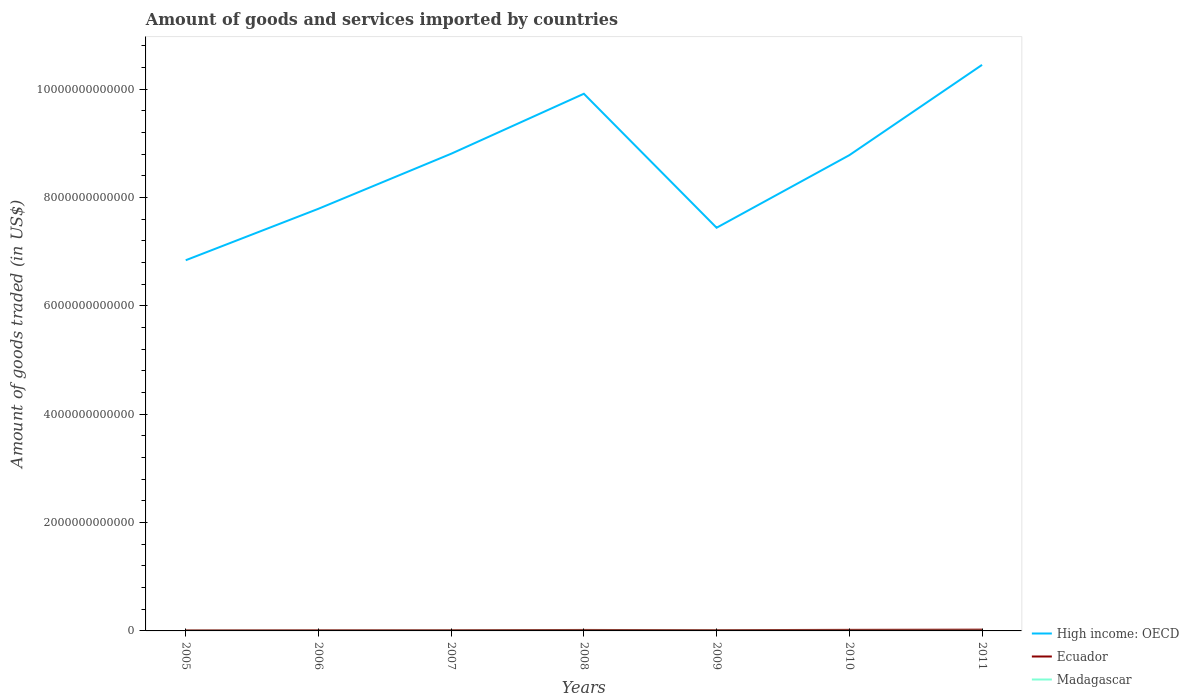Does the line corresponding to Madagascar intersect with the line corresponding to Ecuador?
Provide a succinct answer. No. Across all years, what is the maximum total amount of goods and services imported in Madagascar?
Offer a very short reply. 1.45e+09. In which year was the total amount of goods and services imported in Ecuador maximum?
Keep it short and to the point. 2005. What is the total total amount of goods and services imported in Ecuador in the graph?
Keep it short and to the point. -1.64e+09. What is the difference between the highest and the second highest total amount of goods and services imported in Madagascar?
Give a very brief answer. 1.76e+09. Is the total amount of goods and services imported in Madagascar strictly greater than the total amount of goods and services imported in Ecuador over the years?
Keep it short and to the point. Yes. How many years are there in the graph?
Offer a terse response. 7. What is the difference between two consecutive major ticks on the Y-axis?
Make the answer very short. 2.00e+12. Are the values on the major ticks of Y-axis written in scientific E-notation?
Provide a short and direct response. No. Where does the legend appear in the graph?
Your response must be concise. Bottom right. What is the title of the graph?
Your response must be concise. Amount of goods and services imported by countries. What is the label or title of the X-axis?
Provide a short and direct response. Years. What is the label or title of the Y-axis?
Offer a terse response. Amount of goods traded (in US$). What is the Amount of goods traded (in US$) in High income: OECD in 2005?
Make the answer very short. 6.84e+12. What is the Amount of goods traded (in US$) of Ecuador in 2005?
Provide a succinct answer. 9.70e+09. What is the Amount of goods traded (in US$) in Madagascar in 2005?
Your answer should be compact. 1.45e+09. What is the Amount of goods traded (in US$) in High income: OECD in 2006?
Ensure brevity in your answer.  7.79e+12. What is the Amount of goods traded (in US$) of Ecuador in 2006?
Give a very brief answer. 1.14e+1. What is the Amount of goods traded (in US$) of Madagascar in 2006?
Make the answer very short. 1.54e+09. What is the Amount of goods traded (in US$) in High income: OECD in 2007?
Give a very brief answer. 8.81e+12. What is the Amount of goods traded (in US$) of Ecuador in 2007?
Keep it short and to the point. 1.30e+1. What is the Amount of goods traded (in US$) in Madagascar in 2007?
Provide a short and direct response. 2.25e+09. What is the Amount of goods traded (in US$) of High income: OECD in 2008?
Make the answer very short. 9.91e+12. What is the Amount of goods traded (in US$) in Ecuador in 2008?
Provide a short and direct response. 1.79e+1. What is the Amount of goods traded (in US$) of Madagascar in 2008?
Offer a very short reply. 3.22e+09. What is the Amount of goods traded (in US$) in High income: OECD in 2009?
Your answer should be compact. 7.44e+12. What is the Amount of goods traded (in US$) in Ecuador in 2009?
Make the answer very short. 1.43e+1. What is the Amount of goods traded (in US$) in Madagascar in 2009?
Keep it short and to the point. 2.70e+09. What is the Amount of goods traded (in US$) in High income: OECD in 2010?
Your answer should be very brief. 8.78e+12. What is the Amount of goods traded (in US$) of Ecuador in 2010?
Provide a succinct answer. 1.96e+1. What is the Amount of goods traded (in US$) in Madagascar in 2010?
Your answer should be compact. 2.20e+09. What is the Amount of goods traded (in US$) in High income: OECD in 2011?
Your answer should be compact. 1.04e+13. What is the Amount of goods traded (in US$) of Ecuador in 2011?
Offer a very short reply. 2.32e+1. What is the Amount of goods traded (in US$) of Madagascar in 2011?
Offer a very short reply. 2.47e+09. Across all years, what is the maximum Amount of goods traded (in US$) of High income: OECD?
Your answer should be very brief. 1.04e+13. Across all years, what is the maximum Amount of goods traded (in US$) of Ecuador?
Provide a short and direct response. 2.32e+1. Across all years, what is the maximum Amount of goods traded (in US$) of Madagascar?
Provide a short and direct response. 3.22e+09. Across all years, what is the minimum Amount of goods traded (in US$) in High income: OECD?
Give a very brief answer. 6.84e+12. Across all years, what is the minimum Amount of goods traded (in US$) of Ecuador?
Ensure brevity in your answer.  9.70e+09. Across all years, what is the minimum Amount of goods traded (in US$) in Madagascar?
Offer a very short reply. 1.45e+09. What is the total Amount of goods traded (in US$) in High income: OECD in the graph?
Keep it short and to the point. 6.00e+13. What is the total Amount of goods traded (in US$) in Ecuador in the graph?
Ensure brevity in your answer.  1.09e+11. What is the total Amount of goods traded (in US$) of Madagascar in the graph?
Give a very brief answer. 1.58e+1. What is the difference between the Amount of goods traded (in US$) in High income: OECD in 2005 and that in 2006?
Offer a very short reply. -9.50e+11. What is the difference between the Amount of goods traded (in US$) in Ecuador in 2005 and that in 2006?
Provide a succinct answer. -1.70e+09. What is the difference between the Amount of goods traded (in US$) of Madagascar in 2005 and that in 2006?
Provide a succinct answer. -8.52e+07. What is the difference between the Amount of goods traded (in US$) in High income: OECD in 2005 and that in 2007?
Provide a succinct answer. -1.97e+12. What is the difference between the Amount of goods traded (in US$) of Ecuador in 2005 and that in 2007?
Ensure brevity in your answer.  -3.34e+09. What is the difference between the Amount of goods traded (in US$) of Madagascar in 2005 and that in 2007?
Your answer should be compact. -7.96e+08. What is the difference between the Amount of goods traded (in US$) in High income: OECD in 2005 and that in 2008?
Make the answer very short. -3.07e+12. What is the difference between the Amount of goods traded (in US$) of Ecuador in 2005 and that in 2008?
Ensure brevity in your answer.  -8.20e+09. What is the difference between the Amount of goods traded (in US$) of Madagascar in 2005 and that in 2008?
Ensure brevity in your answer.  -1.76e+09. What is the difference between the Amount of goods traded (in US$) of High income: OECD in 2005 and that in 2009?
Provide a short and direct response. -6.00e+11. What is the difference between the Amount of goods traded (in US$) in Ecuador in 2005 and that in 2009?
Keep it short and to the point. -4.56e+09. What is the difference between the Amount of goods traded (in US$) in Madagascar in 2005 and that in 2009?
Make the answer very short. -1.25e+09. What is the difference between the Amount of goods traded (in US$) in High income: OECD in 2005 and that in 2010?
Your answer should be very brief. -1.94e+12. What is the difference between the Amount of goods traded (in US$) of Ecuador in 2005 and that in 2010?
Ensure brevity in your answer.  -9.93e+09. What is the difference between the Amount of goods traded (in US$) of Madagascar in 2005 and that in 2010?
Ensure brevity in your answer.  -7.46e+08. What is the difference between the Amount of goods traded (in US$) in High income: OECD in 2005 and that in 2011?
Provide a succinct answer. -3.61e+12. What is the difference between the Amount of goods traded (in US$) of Ecuador in 2005 and that in 2011?
Provide a succinct answer. -1.35e+1. What is the difference between the Amount of goods traded (in US$) in Madagascar in 2005 and that in 2011?
Your response must be concise. -1.02e+09. What is the difference between the Amount of goods traded (in US$) in High income: OECD in 2006 and that in 2007?
Offer a terse response. -1.02e+12. What is the difference between the Amount of goods traded (in US$) of Ecuador in 2006 and that in 2007?
Your answer should be very brief. -1.64e+09. What is the difference between the Amount of goods traded (in US$) in Madagascar in 2006 and that in 2007?
Offer a very short reply. -7.11e+08. What is the difference between the Amount of goods traded (in US$) in High income: OECD in 2006 and that in 2008?
Ensure brevity in your answer.  -2.12e+12. What is the difference between the Amount of goods traded (in US$) of Ecuador in 2006 and that in 2008?
Give a very brief answer. -6.50e+09. What is the difference between the Amount of goods traded (in US$) in Madagascar in 2006 and that in 2008?
Your answer should be very brief. -1.68e+09. What is the difference between the Amount of goods traded (in US$) of High income: OECD in 2006 and that in 2009?
Offer a very short reply. 3.50e+11. What is the difference between the Amount of goods traded (in US$) in Ecuador in 2006 and that in 2009?
Offer a very short reply. -2.86e+09. What is the difference between the Amount of goods traded (in US$) in Madagascar in 2006 and that in 2009?
Make the answer very short. -1.17e+09. What is the difference between the Amount of goods traded (in US$) in High income: OECD in 2006 and that in 2010?
Make the answer very short. -9.89e+11. What is the difference between the Amount of goods traded (in US$) of Ecuador in 2006 and that in 2010?
Make the answer very short. -8.23e+09. What is the difference between the Amount of goods traded (in US$) of Madagascar in 2006 and that in 2010?
Keep it short and to the point. -6.61e+08. What is the difference between the Amount of goods traded (in US$) in High income: OECD in 2006 and that in 2011?
Your response must be concise. -2.66e+12. What is the difference between the Amount of goods traded (in US$) in Ecuador in 2006 and that in 2011?
Offer a very short reply. -1.18e+1. What is the difference between the Amount of goods traded (in US$) of Madagascar in 2006 and that in 2011?
Your answer should be very brief. -9.36e+08. What is the difference between the Amount of goods traded (in US$) of High income: OECD in 2007 and that in 2008?
Give a very brief answer. -1.11e+12. What is the difference between the Amount of goods traded (in US$) in Ecuador in 2007 and that in 2008?
Provide a short and direct response. -4.86e+09. What is the difference between the Amount of goods traded (in US$) in Madagascar in 2007 and that in 2008?
Provide a short and direct response. -9.69e+08. What is the difference between the Amount of goods traded (in US$) in High income: OECD in 2007 and that in 2009?
Provide a succinct answer. 1.37e+12. What is the difference between the Amount of goods traded (in US$) of Ecuador in 2007 and that in 2009?
Provide a short and direct response. -1.22e+09. What is the difference between the Amount of goods traded (in US$) in Madagascar in 2007 and that in 2009?
Give a very brief answer. -4.57e+08. What is the difference between the Amount of goods traded (in US$) in High income: OECD in 2007 and that in 2010?
Your answer should be compact. 2.68e+1. What is the difference between the Amount of goods traded (in US$) of Ecuador in 2007 and that in 2010?
Ensure brevity in your answer.  -6.59e+09. What is the difference between the Amount of goods traded (in US$) in Madagascar in 2007 and that in 2010?
Give a very brief answer. 5.01e+07. What is the difference between the Amount of goods traded (in US$) in High income: OECD in 2007 and that in 2011?
Keep it short and to the point. -1.64e+12. What is the difference between the Amount of goods traded (in US$) of Ecuador in 2007 and that in 2011?
Offer a terse response. -1.02e+1. What is the difference between the Amount of goods traded (in US$) in Madagascar in 2007 and that in 2011?
Your answer should be very brief. -2.26e+08. What is the difference between the Amount of goods traded (in US$) of High income: OECD in 2008 and that in 2009?
Your response must be concise. 2.47e+12. What is the difference between the Amount of goods traded (in US$) in Ecuador in 2008 and that in 2009?
Provide a short and direct response. 3.64e+09. What is the difference between the Amount of goods traded (in US$) in Madagascar in 2008 and that in 2009?
Your answer should be very brief. 5.11e+08. What is the difference between the Amount of goods traded (in US$) in High income: OECD in 2008 and that in 2010?
Offer a terse response. 1.13e+12. What is the difference between the Amount of goods traded (in US$) in Ecuador in 2008 and that in 2010?
Your answer should be very brief. -1.73e+09. What is the difference between the Amount of goods traded (in US$) of Madagascar in 2008 and that in 2010?
Offer a very short reply. 1.02e+09. What is the difference between the Amount of goods traded (in US$) of High income: OECD in 2008 and that in 2011?
Provide a succinct answer. -5.33e+11. What is the difference between the Amount of goods traded (in US$) in Ecuador in 2008 and that in 2011?
Your answer should be very brief. -5.33e+09. What is the difference between the Amount of goods traded (in US$) in Madagascar in 2008 and that in 2011?
Provide a succinct answer. 7.43e+08. What is the difference between the Amount of goods traded (in US$) in High income: OECD in 2009 and that in 2010?
Give a very brief answer. -1.34e+12. What is the difference between the Amount of goods traded (in US$) of Ecuador in 2009 and that in 2010?
Ensure brevity in your answer.  -5.37e+09. What is the difference between the Amount of goods traded (in US$) of Madagascar in 2009 and that in 2010?
Offer a terse response. 5.07e+08. What is the difference between the Amount of goods traded (in US$) in High income: OECD in 2009 and that in 2011?
Make the answer very short. -3.01e+12. What is the difference between the Amount of goods traded (in US$) in Ecuador in 2009 and that in 2011?
Your answer should be compact. -8.97e+09. What is the difference between the Amount of goods traded (in US$) in Madagascar in 2009 and that in 2011?
Ensure brevity in your answer.  2.32e+08. What is the difference between the Amount of goods traded (in US$) in High income: OECD in 2010 and that in 2011?
Ensure brevity in your answer.  -1.67e+12. What is the difference between the Amount of goods traded (in US$) in Ecuador in 2010 and that in 2011?
Your answer should be very brief. -3.60e+09. What is the difference between the Amount of goods traded (in US$) of Madagascar in 2010 and that in 2011?
Make the answer very short. -2.76e+08. What is the difference between the Amount of goods traded (in US$) of High income: OECD in 2005 and the Amount of goods traded (in US$) of Ecuador in 2006?
Ensure brevity in your answer.  6.83e+12. What is the difference between the Amount of goods traded (in US$) in High income: OECD in 2005 and the Amount of goods traded (in US$) in Madagascar in 2006?
Your answer should be compact. 6.84e+12. What is the difference between the Amount of goods traded (in US$) in Ecuador in 2005 and the Amount of goods traded (in US$) in Madagascar in 2006?
Make the answer very short. 8.17e+09. What is the difference between the Amount of goods traded (in US$) in High income: OECD in 2005 and the Amount of goods traded (in US$) in Ecuador in 2007?
Make the answer very short. 6.83e+12. What is the difference between the Amount of goods traded (in US$) in High income: OECD in 2005 and the Amount of goods traded (in US$) in Madagascar in 2007?
Your answer should be very brief. 6.84e+12. What is the difference between the Amount of goods traded (in US$) of Ecuador in 2005 and the Amount of goods traded (in US$) of Madagascar in 2007?
Give a very brief answer. 7.46e+09. What is the difference between the Amount of goods traded (in US$) in High income: OECD in 2005 and the Amount of goods traded (in US$) in Ecuador in 2008?
Give a very brief answer. 6.82e+12. What is the difference between the Amount of goods traded (in US$) of High income: OECD in 2005 and the Amount of goods traded (in US$) of Madagascar in 2008?
Offer a terse response. 6.84e+12. What is the difference between the Amount of goods traded (in US$) in Ecuador in 2005 and the Amount of goods traded (in US$) in Madagascar in 2008?
Provide a short and direct response. 6.49e+09. What is the difference between the Amount of goods traded (in US$) of High income: OECD in 2005 and the Amount of goods traded (in US$) of Ecuador in 2009?
Make the answer very short. 6.83e+12. What is the difference between the Amount of goods traded (in US$) of High income: OECD in 2005 and the Amount of goods traded (in US$) of Madagascar in 2009?
Your response must be concise. 6.84e+12. What is the difference between the Amount of goods traded (in US$) of Ecuador in 2005 and the Amount of goods traded (in US$) of Madagascar in 2009?
Keep it short and to the point. 7.00e+09. What is the difference between the Amount of goods traded (in US$) of High income: OECD in 2005 and the Amount of goods traded (in US$) of Ecuador in 2010?
Make the answer very short. 6.82e+12. What is the difference between the Amount of goods traded (in US$) in High income: OECD in 2005 and the Amount of goods traded (in US$) in Madagascar in 2010?
Provide a short and direct response. 6.84e+12. What is the difference between the Amount of goods traded (in US$) in Ecuador in 2005 and the Amount of goods traded (in US$) in Madagascar in 2010?
Your answer should be very brief. 7.51e+09. What is the difference between the Amount of goods traded (in US$) in High income: OECD in 2005 and the Amount of goods traded (in US$) in Ecuador in 2011?
Make the answer very short. 6.82e+12. What is the difference between the Amount of goods traded (in US$) of High income: OECD in 2005 and the Amount of goods traded (in US$) of Madagascar in 2011?
Your answer should be compact. 6.84e+12. What is the difference between the Amount of goods traded (in US$) in Ecuador in 2005 and the Amount of goods traded (in US$) in Madagascar in 2011?
Offer a terse response. 7.23e+09. What is the difference between the Amount of goods traded (in US$) in High income: OECD in 2006 and the Amount of goods traded (in US$) in Ecuador in 2007?
Offer a terse response. 7.78e+12. What is the difference between the Amount of goods traded (in US$) in High income: OECD in 2006 and the Amount of goods traded (in US$) in Madagascar in 2007?
Provide a short and direct response. 7.79e+12. What is the difference between the Amount of goods traded (in US$) of Ecuador in 2006 and the Amount of goods traded (in US$) of Madagascar in 2007?
Give a very brief answer. 9.15e+09. What is the difference between the Amount of goods traded (in US$) of High income: OECD in 2006 and the Amount of goods traded (in US$) of Ecuador in 2008?
Your response must be concise. 7.77e+12. What is the difference between the Amount of goods traded (in US$) in High income: OECD in 2006 and the Amount of goods traded (in US$) in Madagascar in 2008?
Provide a succinct answer. 7.79e+12. What is the difference between the Amount of goods traded (in US$) in Ecuador in 2006 and the Amount of goods traded (in US$) in Madagascar in 2008?
Make the answer very short. 8.19e+09. What is the difference between the Amount of goods traded (in US$) of High income: OECD in 2006 and the Amount of goods traded (in US$) of Ecuador in 2009?
Ensure brevity in your answer.  7.78e+12. What is the difference between the Amount of goods traded (in US$) of High income: OECD in 2006 and the Amount of goods traded (in US$) of Madagascar in 2009?
Offer a terse response. 7.79e+12. What is the difference between the Amount of goods traded (in US$) in Ecuador in 2006 and the Amount of goods traded (in US$) in Madagascar in 2009?
Make the answer very short. 8.70e+09. What is the difference between the Amount of goods traded (in US$) of High income: OECD in 2006 and the Amount of goods traded (in US$) of Ecuador in 2010?
Your answer should be compact. 7.77e+12. What is the difference between the Amount of goods traded (in US$) in High income: OECD in 2006 and the Amount of goods traded (in US$) in Madagascar in 2010?
Make the answer very short. 7.79e+12. What is the difference between the Amount of goods traded (in US$) in Ecuador in 2006 and the Amount of goods traded (in US$) in Madagascar in 2010?
Keep it short and to the point. 9.20e+09. What is the difference between the Amount of goods traded (in US$) of High income: OECD in 2006 and the Amount of goods traded (in US$) of Ecuador in 2011?
Your answer should be very brief. 7.77e+12. What is the difference between the Amount of goods traded (in US$) of High income: OECD in 2006 and the Amount of goods traded (in US$) of Madagascar in 2011?
Your answer should be compact. 7.79e+12. What is the difference between the Amount of goods traded (in US$) of Ecuador in 2006 and the Amount of goods traded (in US$) of Madagascar in 2011?
Provide a short and direct response. 8.93e+09. What is the difference between the Amount of goods traded (in US$) in High income: OECD in 2007 and the Amount of goods traded (in US$) in Ecuador in 2008?
Your response must be concise. 8.79e+12. What is the difference between the Amount of goods traded (in US$) in High income: OECD in 2007 and the Amount of goods traded (in US$) in Madagascar in 2008?
Your answer should be compact. 8.80e+12. What is the difference between the Amount of goods traded (in US$) in Ecuador in 2007 and the Amount of goods traded (in US$) in Madagascar in 2008?
Provide a succinct answer. 9.83e+09. What is the difference between the Amount of goods traded (in US$) in High income: OECD in 2007 and the Amount of goods traded (in US$) in Ecuador in 2009?
Give a very brief answer. 8.79e+12. What is the difference between the Amount of goods traded (in US$) of High income: OECD in 2007 and the Amount of goods traded (in US$) of Madagascar in 2009?
Keep it short and to the point. 8.80e+12. What is the difference between the Amount of goods traded (in US$) in Ecuador in 2007 and the Amount of goods traded (in US$) in Madagascar in 2009?
Your answer should be compact. 1.03e+1. What is the difference between the Amount of goods traded (in US$) of High income: OECD in 2007 and the Amount of goods traded (in US$) of Ecuador in 2010?
Make the answer very short. 8.79e+12. What is the difference between the Amount of goods traded (in US$) of High income: OECD in 2007 and the Amount of goods traded (in US$) of Madagascar in 2010?
Give a very brief answer. 8.81e+12. What is the difference between the Amount of goods traded (in US$) in Ecuador in 2007 and the Amount of goods traded (in US$) in Madagascar in 2010?
Make the answer very short. 1.08e+1. What is the difference between the Amount of goods traded (in US$) in High income: OECD in 2007 and the Amount of goods traded (in US$) in Ecuador in 2011?
Ensure brevity in your answer.  8.78e+12. What is the difference between the Amount of goods traded (in US$) in High income: OECD in 2007 and the Amount of goods traded (in US$) in Madagascar in 2011?
Offer a very short reply. 8.80e+12. What is the difference between the Amount of goods traded (in US$) of Ecuador in 2007 and the Amount of goods traded (in US$) of Madagascar in 2011?
Make the answer very short. 1.06e+1. What is the difference between the Amount of goods traded (in US$) in High income: OECD in 2008 and the Amount of goods traded (in US$) in Ecuador in 2009?
Provide a succinct answer. 9.90e+12. What is the difference between the Amount of goods traded (in US$) in High income: OECD in 2008 and the Amount of goods traded (in US$) in Madagascar in 2009?
Offer a terse response. 9.91e+12. What is the difference between the Amount of goods traded (in US$) of Ecuador in 2008 and the Amount of goods traded (in US$) of Madagascar in 2009?
Provide a succinct answer. 1.52e+1. What is the difference between the Amount of goods traded (in US$) of High income: OECD in 2008 and the Amount of goods traded (in US$) of Ecuador in 2010?
Offer a terse response. 9.89e+12. What is the difference between the Amount of goods traded (in US$) in High income: OECD in 2008 and the Amount of goods traded (in US$) in Madagascar in 2010?
Give a very brief answer. 9.91e+12. What is the difference between the Amount of goods traded (in US$) in Ecuador in 2008 and the Amount of goods traded (in US$) in Madagascar in 2010?
Make the answer very short. 1.57e+1. What is the difference between the Amount of goods traded (in US$) of High income: OECD in 2008 and the Amount of goods traded (in US$) of Ecuador in 2011?
Give a very brief answer. 9.89e+12. What is the difference between the Amount of goods traded (in US$) in High income: OECD in 2008 and the Amount of goods traded (in US$) in Madagascar in 2011?
Provide a short and direct response. 9.91e+12. What is the difference between the Amount of goods traded (in US$) of Ecuador in 2008 and the Amount of goods traded (in US$) of Madagascar in 2011?
Your answer should be very brief. 1.54e+1. What is the difference between the Amount of goods traded (in US$) of High income: OECD in 2009 and the Amount of goods traded (in US$) of Ecuador in 2010?
Make the answer very short. 7.42e+12. What is the difference between the Amount of goods traded (in US$) in High income: OECD in 2009 and the Amount of goods traded (in US$) in Madagascar in 2010?
Your answer should be compact. 7.44e+12. What is the difference between the Amount of goods traded (in US$) in Ecuador in 2009 and the Amount of goods traded (in US$) in Madagascar in 2010?
Keep it short and to the point. 1.21e+1. What is the difference between the Amount of goods traded (in US$) in High income: OECD in 2009 and the Amount of goods traded (in US$) in Ecuador in 2011?
Make the answer very short. 7.42e+12. What is the difference between the Amount of goods traded (in US$) in High income: OECD in 2009 and the Amount of goods traded (in US$) in Madagascar in 2011?
Keep it short and to the point. 7.44e+12. What is the difference between the Amount of goods traded (in US$) of Ecuador in 2009 and the Amount of goods traded (in US$) of Madagascar in 2011?
Offer a very short reply. 1.18e+1. What is the difference between the Amount of goods traded (in US$) of High income: OECD in 2010 and the Amount of goods traded (in US$) of Ecuador in 2011?
Ensure brevity in your answer.  8.76e+12. What is the difference between the Amount of goods traded (in US$) in High income: OECD in 2010 and the Amount of goods traded (in US$) in Madagascar in 2011?
Provide a succinct answer. 8.78e+12. What is the difference between the Amount of goods traded (in US$) of Ecuador in 2010 and the Amount of goods traded (in US$) of Madagascar in 2011?
Your answer should be compact. 1.72e+1. What is the average Amount of goods traded (in US$) of High income: OECD per year?
Your answer should be very brief. 8.57e+12. What is the average Amount of goods traded (in US$) of Ecuador per year?
Ensure brevity in your answer.  1.56e+1. What is the average Amount of goods traded (in US$) of Madagascar per year?
Your answer should be very brief. 2.26e+09. In the year 2005, what is the difference between the Amount of goods traded (in US$) of High income: OECD and Amount of goods traded (in US$) of Ecuador?
Keep it short and to the point. 6.83e+12. In the year 2005, what is the difference between the Amount of goods traded (in US$) in High income: OECD and Amount of goods traded (in US$) in Madagascar?
Give a very brief answer. 6.84e+12. In the year 2005, what is the difference between the Amount of goods traded (in US$) in Ecuador and Amount of goods traded (in US$) in Madagascar?
Provide a succinct answer. 8.25e+09. In the year 2006, what is the difference between the Amount of goods traded (in US$) of High income: OECD and Amount of goods traded (in US$) of Ecuador?
Your answer should be compact. 7.78e+12. In the year 2006, what is the difference between the Amount of goods traded (in US$) in High income: OECD and Amount of goods traded (in US$) in Madagascar?
Your response must be concise. 7.79e+12. In the year 2006, what is the difference between the Amount of goods traded (in US$) in Ecuador and Amount of goods traded (in US$) in Madagascar?
Offer a very short reply. 9.87e+09. In the year 2007, what is the difference between the Amount of goods traded (in US$) of High income: OECD and Amount of goods traded (in US$) of Ecuador?
Provide a succinct answer. 8.79e+12. In the year 2007, what is the difference between the Amount of goods traded (in US$) of High income: OECD and Amount of goods traded (in US$) of Madagascar?
Offer a terse response. 8.81e+12. In the year 2007, what is the difference between the Amount of goods traded (in US$) of Ecuador and Amount of goods traded (in US$) of Madagascar?
Offer a terse response. 1.08e+1. In the year 2008, what is the difference between the Amount of goods traded (in US$) in High income: OECD and Amount of goods traded (in US$) in Ecuador?
Give a very brief answer. 9.90e+12. In the year 2008, what is the difference between the Amount of goods traded (in US$) in High income: OECD and Amount of goods traded (in US$) in Madagascar?
Make the answer very short. 9.91e+12. In the year 2008, what is the difference between the Amount of goods traded (in US$) of Ecuador and Amount of goods traded (in US$) of Madagascar?
Give a very brief answer. 1.47e+1. In the year 2009, what is the difference between the Amount of goods traded (in US$) in High income: OECD and Amount of goods traded (in US$) in Ecuador?
Make the answer very short. 7.43e+12. In the year 2009, what is the difference between the Amount of goods traded (in US$) of High income: OECD and Amount of goods traded (in US$) of Madagascar?
Your answer should be compact. 7.44e+12. In the year 2009, what is the difference between the Amount of goods traded (in US$) in Ecuador and Amount of goods traded (in US$) in Madagascar?
Ensure brevity in your answer.  1.16e+1. In the year 2010, what is the difference between the Amount of goods traded (in US$) in High income: OECD and Amount of goods traded (in US$) in Ecuador?
Your answer should be very brief. 8.76e+12. In the year 2010, what is the difference between the Amount of goods traded (in US$) of High income: OECD and Amount of goods traded (in US$) of Madagascar?
Offer a terse response. 8.78e+12. In the year 2010, what is the difference between the Amount of goods traded (in US$) of Ecuador and Amount of goods traded (in US$) of Madagascar?
Your answer should be compact. 1.74e+1. In the year 2011, what is the difference between the Amount of goods traded (in US$) of High income: OECD and Amount of goods traded (in US$) of Ecuador?
Your answer should be compact. 1.04e+13. In the year 2011, what is the difference between the Amount of goods traded (in US$) of High income: OECD and Amount of goods traded (in US$) of Madagascar?
Ensure brevity in your answer.  1.04e+13. In the year 2011, what is the difference between the Amount of goods traded (in US$) in Ecuador and Amount of goods traded (in US$) in Madagascar?
Offer a terse response. 2.08e+1. What is the ratio of the Amount of goods traded (in US$) in High income: OECD in 2005 to that in 2006?
Your response must be concise. 0.88. What is the ratio of the Amount of goods traded (in US$) of Ecuador in 2005 to that in 2006?
Offer a very short reply. 0.85. What is the ratio of the Amount of goods traded (in US$) of Madagascar in 2005 to that in 2006?
Keep it short and to the point. 0.94. What is the ratio of the Amount of goods traded (in US$) of High income: OECD in 2005 to that in 2007?
Your answer should be compact. 0.78. What is the ratio of the Amount of goods traded (in US$) in Ecuador in 2005 to that in 2007?
Your answer should be very brief. 0.74. What is the ratio of the Amount of goods traded (in US$) of Madagascar in 2005 to that in 2007?
Provide a succinct answer. 0.65. What is the ratio of the Amount of goods traded (in US$) of High income: OECD in 2005 to that in 2008?
Ensure brevity in your answer.  0.69. What is the ratio of the Amount of goods traded (in US$) in Ecuador in 2005 to that in 2008?
Your response must be concise. 0.54. What is the ratio of the Amount of goods traded (in US$) in Madagascar in 2005 to that in 2008?
Provide a succinct answer. 0.45. What is the ratio of the Amount of goods traded (in US$) of High income: OECD in 2005 to that in 2009?
Offer a terse response. 0.92. What is the ratio of the Amount of goods traded (in US$) of Ecuador in 2005 to that in 2009?
Offer a very short reply. 0.68. What is the ratio of the Amount of goods traded (in US$) of Madagascar in 2005 to that in 2009?
Ensure brevity in your answer.  0.54. What is the ratio of the Amount of goods traded (in US$) of High income: OECD in 2005 to that in 2010?
Your response must be concise. 0.78. What is the ratio of the Amount of goods traded (in US$) in Ecuador in 2005 to that in 2010?
Give a very brief answer. 0.49. What is the ratio of the Amount of goods traded (in US$) in Madagascar in 2005 to that in 2010?
Provide a short and direct response. 0.66. What is the ratio of the Amount of goods traded (in US$) of High income: OECD in 2005 to that in 2011?
Keep it short and to the point. 0.65. What is the ratio of the Amount of goods traded (in US$) of Ecuador in 2005 to that in 2011?
Give a very brief answer. 0.42. What is the ratio of the Amount of goods traded (in US$) of Madagascar in 2005 to that in 2011?
Your answer should be very brief. 0.59. What is the ratio of the Amount of goods traded (in US$) of High income: OECD in 2006 to that in 2007?
Your response must be concise. 0.88. What is the ratio of the Amount of goods traded (in US$) in Ecuador in 2006 to that in 2007?
Provide a succinct answer. 0.87. What is the ratio of the Amount of goods traded (in US$) in Madagascar in 2006 to that in 2007?
Make the answer very short. 0.68. What is the ratio of the Amount of goods traded (in US$) of High income: OECD in 2006 to that in 2008?
Make the answer very short. 0.79. What is the ratio of the Amount of goods traded (in US$) of Ecuador in 2006 to that in 2008?
Your response must be concise. 0.64. What is the ratio of the Amount of goods traded (in US$) in Madagascar in 2006 to that in 2008?
Your answer should be compact. 0.48. What is the ratio of the Amount of goods traded (in US$) of High income: OECD in 2006 to that in 2009?
Ensure brevity in your answer.  1.05. What is the ratio of the Amount of goods traded (in US$) in Ecuador in 2006 to that in 2009?
Your answer should be compact. 0.8. What is the ratio of the Amount of goods traded (in US$) in Madagascar in 2006 to that in 2009?
Your response must be concise. 0.57. What is the ratio of the Amount of goods traded (in US$) in High income: OECD in 2006 to that in 2010?
Keep it short and to the point. 0.89. What is the ratio of the Amount of goods traded (in US$) of Ecuador in 2006 to that in 2010?
Your answer should be compact. 0.58. What is the ratio of the Amount of goods traded (in US$) in Madagascar in 2006 to that in 2010?
Your answer should be very brief. 0.7. What is the ratio of the Amount of goods traded (in US$) in High income: OECD in 2006 to that in 2011?
Make the answer very short. 0.75. What is the ratio of the Amount of goods traded (in US$) in Ecuador in 2006 to that in 2011?
Your answer should be compact. 0.49. What is the ratio of the Amount of goods traded (in US$) in Madagascar in 2006 to that in 2011?
Provide a succinct answer. 0.62. What is the ratio of the Amount of goods traded (in US$) of High income: OECD in 2007 to that in 2008?
Offer a terse response. 0.89. What is the ratio of the Amount of goods traded (in US$) of Ecuador in 2007 to that in 2008?
Provide a succinct answer. 0.73. What is the ratio of the Amount of goods traded (in US$) in Madagascar in 2007 to that in 2008?
Make the answer very short. 0.7. What is the ratio of the Amount of goods traded (in US$) in High income: OECD in 2007 to that in 2009?
Your answer should be compact. 1.18. What is the ratio of the Amount of goods traded (in US$) of Ecuador in 2007 to that in 2009?
Your response must be concise. 0.91. What is the ratio of the Amount of goods traded (in US$) in Madagascar in 2007 to that in 2009?
Ensure brevity in your answer.  0.83. What is the ratio of the Amount of goods traded (in US$) in Ecuador in 2007 to that in 2010?
Offer a terse response. 0.66. What is the ratio of the Amount of goods traded (in US$) in Madagascar in 2007 to that in 2010?
Give a very brief answer. 1.02. What is the ratio of the Amount of goods traded (in US$) in High income: OECD in 2007 to that in 2011?
Provide a short and direct response. 0.84. What is the ratio of the Amount of goods traded (in US$) of Ecuador in 2007 to that in 2011?
Give a very brief answer. 0.56. What is the ratio of the Amount of goods traded (in US$) in Madagascar in 2007 to that in 2011?
Provide a short and direct response. 0.91. What is the ratio of the Amount of goods traded (in US$) of High income: OECD in 2008 to that in 2009?
Your response must be concise. 1.33. What is the ratio of the Amount of goods traded (in US$) of Ecuador in 2008 to that in 2009?
Offer a very short reply. 1.26. What is the ratio of the Amount of goods traded (in US$) of Madagascar in 2008 to that in 2009?
Keep it short and to the point. 1.19. What is the ratio of the Amount of goods traded (in US$) of High income: OECD in 2008 to that in 2010?
Provide a short and direct response. 1.13. What is the ratio of the Amount of goods traded (in US$) of Ecuador in 2008 to that in 2010?
Your answer should be compact. 0.91. What is the ratio of the Amount of goods traded (in US$) of Madagascar in 2008 to that in 2010?
Provide a short and direct response. 1.46. What is the ratio of the Amount of goods traded (in US$) in High income: OECD in 2008 to that in 2011?
Provide a short and direct response. 0.95. What is the ratio of the Amount of goods traded (in US$) of Ecuador in 2008 to that in 2011?
Ensure brevity in your answer.  0.77. What is the ratio of the Amount of goods traded (in US$) of Madagascar in 2008 to that in 2011?
Ensure brevity in your answer.  1.3. What is the ratio of the Amount of goods traded (in US$) of High income: OECD in 2009 to that in 2010?
Your answer should be compact. 0.85. What is the ratio of the Amount of goods traded (in US$) in Ecuador in 2009 to that in 2010?
Your answer should be very brief. 0.73. What is the ratio of the Amount of goods traded (in US$) of Madagascar in 2009 to that in 2010?
Keep it short and to the point. 1.23. What is the ratio of the Amount of goods traded (in US$) in High income: OECD in 2009 to that in 2011?
Your response must be concise. 0.71. What is the ratio of the Amount of goods traded (in US$) in Ecuador in 2009 to that in 2011?
Offer a very short reply. 0.61. What is the ratio of the Amount of goods traded (in US$) of Madagascar in 2009 to that in 2011?
Give a very brief answer. 1.09. What is the ratio of the Amount of goods traded (in US$) of High income: OECD in 2010 to that in 2011?
Make the answer very short. 0.84. What is the ratio of the Amount of goods traded (in US$) in Ecuador in 2010 to that in 2011?
Your response must be concise. 0.84. What is the ratio of the Amount of goods traded (in US$) of Madagascar in 2010 to that in 2011?
Your response must be concise. 0.89. What is the difference between the highest and the second highest Amount of goods traded (in US$) of High income: OECD?
Provide a short and direct response. 5.33e+11. What is the difference between the highest and the second highest Amount of goods traded (in US$) in Ecuador?
Offer a terse response. 3.60e+09. What is the difference between the highest and the second highest Amount of goods traded (in US$) of Madagascar?
Offer a terse response. 5.11e+08. What is the difference between the highest and the lowest Amount of goods traded (in US$) of High income: OECD?
Ensure brevity in your answer.  3.61e+12. What is the difference between the highest and the lowest Amount of goods traded (in US$) in Ecuador?
Keep it short and to the point. 1.35e+1. What is the difference between the highest and the lowest Amount of goods traded (in US$) in Madagascar?
Your answer should be very brief. 1.76e+09. 